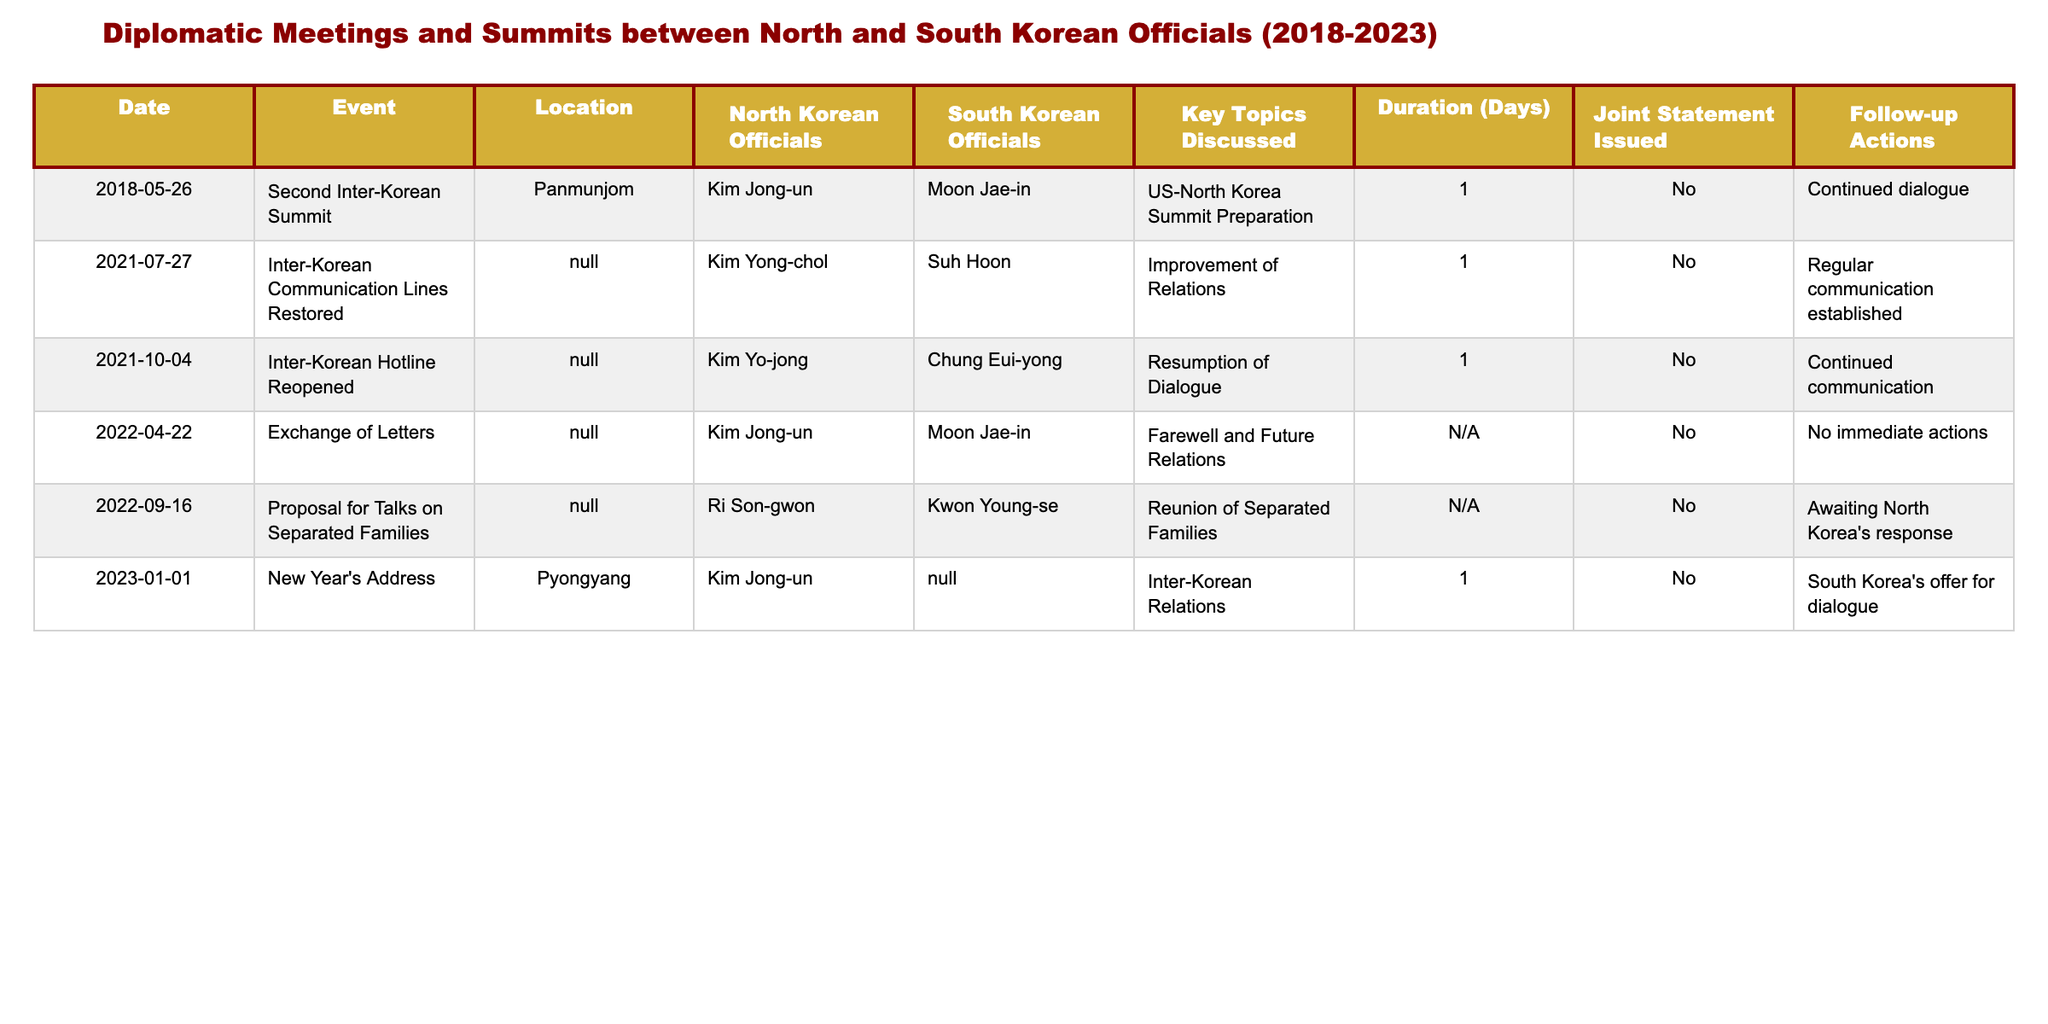What was the date of the Second Inter-Korean Summit? The table lists the date of the Second Inter-Korean Summit as May 26, 2018.
Answer: May 26, 2018 Who represented South Korea in the 2021 Inter-Korean Communication Lines Restoration meeting? The table shows that Suh Hoon represented South Korea in the 2021 meeting on July 27.
Answer: Suh Hoon How many days did the Second Inter-Korean Summit last? According to the table, the duration of the Second Inter-Korean Summit was 1 day.
Answer: 1 day Was a joint statement issued during the 2022 Exchange of Letters? The table indicates that no joint statement was issued for the Exchange of Letters held on April 22, 2022.
Answer: No How many diplomatic events involved Kim Jong-un as a North Korean official? By reviewing the table, Kim Jong-un participated in three events: the Second Inter-Korean Summit, the Exchange of Letters, and the New Year's Address. The count is 3.
Answer: 3 What key topic was discussed during the meeting on January 1, 2023? The table notes that the key topic discussed during the New Year's Address was inter-Korean relations.
Answer: Inter-Korean relations Did any of the diplomatic meetings result in immediate follow-up actions? A review of the table shows that none of the listed meetings resulted in immediate follow-up actions, as indicated by "No immediate actions" in the follow-up actions column for each event.
Answer: No Which official from North Korea was present at the Proposal for Talks on Separated Families? The table states that Ri Son-gwon from North Korea was present at the Proposal for Talks on Separated Families on September 16, 2022.
Answer: Ri Son-gwon How many meetings discussed the topic of family reunions? The table reveals that only one meeting, the Proposal for Talks on Separated Families, specifically discussed the reunion of separated families, counting as 1.
Answer: 1 Which location hosted the New Year's Address in 2023? According to the table, the New Year's Address took place in Pyongyang.
Answer: Pyongyang 